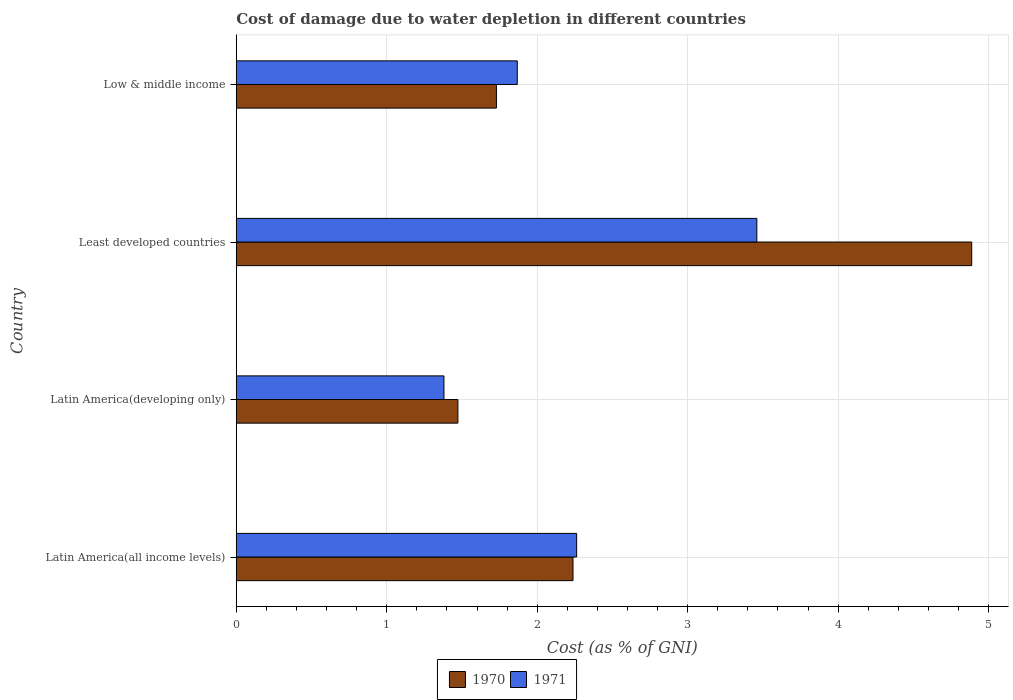How many bars are there on the 2nd tick from the top?
Make the answer very short. 2. What is the label of the 2nd group of bars from the top?
Ensure brevity in your answer.  Least developed countries. In how many cases, is the number of bars for a given country not equal to the number of legend labels?
Your answer should be compact. 0. What is the cost of damage caused due to water depletion in 1971 in Low & middle income?
Your response must be concise. 1.87. Across all countries, what is the maximum cost of damage caused due to water depletion in 1971?
Your response must be concise. 3.46. Across all countries, what is the minimum cost of damage caused due to water depletion in 1971?
Your answer should be compact. 1.38. In which country was the cost of damage caused due to water depletion in 1971 maximum?
Make the answer very short. Least developed countries. In which country was the cost of damage caused due to water depletion in 1970 minimum?
Provide a short and direct response. Latin America(developing only). What is the total cost of damage caused due to water depletion in 1970 in the graph?
Keep it short and to the point. 10.33. What is the difference between the cost of damage caused due to water depletion in 1971 in Latin America(all income levels) and that in Low & middle income?
Keep it short and to the point. 0.39. What is the difference between the cost of damage caused due to water depletion in 1970 in Least developed countries and the cost of damage caused due to water depletion in 1971 in Latin America(developing only)?
Your response must be concise. 3.51. What is the average cost of damage caused due to water depletion in 1970 per country?
Your response must be concise. 2.58. What is the difference between the cost of damage caused due to water depletion in 1970 and cost of damage caused due to water depletion in 1971 in Latin America(all income levels)?
Your answer should be very brief. -0.02. What is the ratio of the cost of damage caused due to water depletion in 1971 in Latin America(all income levels) to that in Latin America(developing only)?
Keep it short and to the point. 1.64. Is the cost of damage caused due to water depletion in 1970 in Latin America(all income levels) less than that in Least developed countries?
Make the answer very short. Yes. Is the difference between the cost of damage caused due to water depletion in 1970 in Latin America(developing only) and Least developed countries greater than the difference between the cost of damage caused due to water depletion in 1971 in Latin America(developing only) and Least developed countries?
Provide a succinct answer. No. What is the difference between the highest and the second highest cost of damage caused due to water depletion in 1970?
Your answer should be compact. 2.65. What is the difference between the highest and the lowest cost of damage caused due to water depletion in 1970?
Give a very brief answer. 3.41. Is the sum of the cost of damage caused due to water depletion in 1971 in Least developed countries and Low & middle income greater than the maximum cost of damage caused due to water depletion in 1970 across all countries?
Provide a short and direct response. Yes. What does the 1st bar from the bottom in Low & middle income represents?
Make the answer very short. 1970. Are all the bars in the graph horizontal?
Offer a terse response. Yes. Are the values on the major ticks of X-axis written in scientific E-notation?
Offer a very short reply. No. How many legend labels are there?
Ensure brevity in your answer.  2. What is the title of the graph?
Your answer should be compact. Cost of damage due to water depletion in different countries. What is the label or title of the X-axis?
Give a very brief answer. Cost (as % of GNI). What is the Cost (as % of GNI) in 1970 in Latin America(all income levels)?
Your response must be concise. 2.24. What is the Cost (as % of GNI) of 1971 in Latin America(all income levels)?
Offer a very short reply. 2.26. What is the Cost (as % of GNI) of 1970 in Latin America(developing only)?
Your response must be concise. 1.47. What is the Cost (as % of GNI) in 1971 in Latin America(developing only)?
Your response must be concise. 1.38. What is the Cost (as % of GNI) in 1970 in Least developed countries?
Give a very brief answer. 4.89. What is the Cost (as % of GNI) in 1971 in Least developed countries?
Make the answer very short. 3.46. What is the Cost (as % of GNI) in 1970 in Low & middle income?
Ensure brevity in your answer.  1.73. What is the Cost (as % of GNI) of 1971 in Low & middle income?
Make the answer very short. 1.87. Across all countries, what is the maximum Cost (as % of GNI) in 1970?
Provide a short and direct response. 4.89. Across all countries, what is the maximum Cost (as % of GNI) of 1971?
Offer a very short reply. 3.46. Across all countries, what is the minimum Cost (as % of GNI) in 1970?
Provide a succinct answer. 1.47. Across all countries, what is the minimum Cost (as % of GNI) in 1971?
Your response must be concise. 1.38. What is the total Cost (as % of GNI) of 1970 in the graph?
Make the answer very short. 10.33. What is the total Cost (as % of GNI) in 1971 in the graph?
Provide a succinct answer. 8.97. What is the difference between the Cost (as % of GNI) in 1970 in Latin America(all income levels) and that in Latin America(developing only)?
Offer a very short reply. 0.76. What is the difference between the Cost (as % of GNI) in 1971 in Latin America(all income levels) and that in Latin America(developing only)?
Your answer should be very brief. 0.88. What is the difference between the Cost (as % of GNI) in 1970 in Latin America(all income levels) and that in Least developed countries?
Your response must be concise. -2.65. What is the difference between the Cost (as % of GNI) of 1971 in Latin America(all income levels) and that in Least developed countries?
Make the answer very short. -1.2. What is the difference between the Cost (as % of GNI) in 1970 in Latin America(all income levels) and that in Low & middle income?
Provide a succinct answer. 0.51. What is the difference between the Cost (as % of GNI) in 1971 in Latin America(all income levels) and that in Low & middle income?
Keep it short and to the point. 0.39. What is the difference between the Cost (as % of GNI) in 1970 in Latin America(developing only) and that in Least developed countries?
Provide a succinct answer. -3.41. What is the difference between the Cost (as % of GNI) of 1971 in Latin America(developing only) and that in Least developed countries?
Give a very brief answer. -2.08. What is the difference between the Cost (as % of GNI) of 1970 in Latin America(developing only) and that in Low & middle income?
Offer a terse response. -0.26. What is the difference between the Cost (as % of GNI) in 1971 in Latin America(developing only) and that in Low & middle income?
Give a very brief answer. -0.49. What is the difference between the Cost (as % of GNI) in 1970 in Least developed countries and that in Low & middle income?
Offer a very short reply. 3.16. What is the difference between the Cost (as % of GNI) in 1971 in Least developed countries and that in Low & middle income?
Your response must be concise. 1.59. What is the difference between the Cost (as % of GNI) in 1970 in Latin America(all income levels) and the Cost (as % of GNI) in 1971 in Latin America(developing only)?
Your answer should be very brief. 0.86. What is the difference between the Cost (as % of GNI) in 1970 in Latin America(all income levels) and the Cost (as % of GNI) in 1971 in Least developed countries?
Give a very brief answer. -1.22. What is the difference between the Cost (as % of GNI) in 1970 in Latin America(all income levels) and the Cost (as % of GNI) in 1971 in Low & middle income?
Ensure brevity in your answer.  0.37. What is the difference between the Cost (as % of GNI) of 1970 in Latin America(developing only) and the Cost (as % of GNI) of 1971 in Least developed countries?
Your answer should be compact. -1.99. What is the difference between the Cost (as % of GNI) in 1970 in Latin America(developing only) and the Cost (as % of GNI) in 1971 in Low & middle income?
Keep it short and to the point. -0.39. What is the difference between the Cost (as % of GNI) in 1970 in Least developed countries and the Cost (as % of GNI) in 1971 in Low & middle income?
Provide a succinct answer. 3.02. What is the average Cost (as % of GNI) in 1970 per country?
Offer a very short reply. 2.58. What is the average Cost (as % of GNI) of 1971 per country?
Your answer should be compact. 2.24. What is the difference between the Cost (as % of GNI) in 1970 and Cost (as % of GNI) in 1971 in Latin America(all income levels)?
Ensure brevity in your answer.  -0.02. What is the difference between the Cost (as % of GNI) in 1970 and Cost (as % of GNI) in 1971 in Latin America(developing only)?
Make the answer very short. 0.09. What is the difference between the Cost (as % of GNI) of 1970 and Cost (as % of GNI) of 1971 in Least developed countries?
Ensure brevity in your answer.  1.43. What is the difference between the Cost (as % of GNI) in 1970 and Cost (as % of GNI) in 1971 in Low & middle income?
Provide a succinct answer. -0.14. What is the ratio of the Cost (as % of GNI) of 1970 in Latin America(all income levels) to that in Latin America(developing only)?
Your response must be concise. 1.52. What is the ratio of the Cost (as % of GNI) of 1971 in Latin America(all income levels) to that in Latin America(developing only)?
Ensure brevity in your answer.  1.64. What is the ratio of the Cost (as % of GNI) in 1970 in Latin America(all income levels) to that in Least developed countries?
Provide a short and direct response. 0.46. What is the ratio of the Cost (as % of GNI) of 1971 in Latin America(all income levels) to that in Least developed countries?
Ensure brevity in your answer.  0.65. What is the ratio of the Cost (as % of GNI) in 1970 in Latin America(all income levels) to that in Low & middle income?
Keep it short and to the point. 1.29. What is the ratio of the Cost (as % of GNI) of 1971 in Latin America(all income levels) to that in Low & middle income?
Provide a short and direct response. 1.21. What is the ratio of the Cost (as % of GNI) in 1970 in Latin America(developing only) to that in Least developed countries?
Your answer should be compact. 0.3. What is the ratio of the Cost (as % of GNI) in 1971 in Latin America(developing only) to that in Least developed countries?
Offer a terse response. 0.4. What is the ratio of the Cost (as % of GNI) in 1970 in Latin America(developing only) to that in Low & middle income?
Give a very brief answer. 0.85. What is the ratio of the Cost (as % of GNI) of 1971 in Latin America(developing only) to that in Low & middle income?
Your response must be concise. 0.74. What is the ratio of the Cost (as % of GNI) in 1970 in Least developed countries to that in Low & middle income?
Your answer should be very brief. 2.83. What is the ratio of the Cost (as % of GNI) in 1971 in Least developed countries to that in Low & middle income?
Give a very brief answer. 1.85. What is the difference between the highest and the second highest Cost (as % of GNI) of 1970?
Make the answer very short. 2.65. What is the difference between the highest and the second highest Cost (as % of GNI) of 1971?
Make the answer very short. 1.2. What is the difference between the highest and the lowest Cost (as % of GNI) in 1970?
Ensure brevity in your answer.  3.41. What is the difference between the highest and the lowest Cost (as % of GNI) of 1971?
Your answer should be very brief. 2.08. 